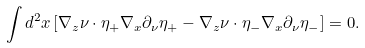<formula> <loc_0><loc_0><loc_500><loc_500>\int d ^ { 2 } x \left [ \nabla _ { z } \nu \cdot \eta _ { + } \nabla _ { x } \partial _ { \nu } \eta _ { + } - \nabla _ { z } \nu \cdot \eta _ { - } \nabla _ { x } \partial _ { \nu } \eta _ { - } \right ] = 0 .</formula> 